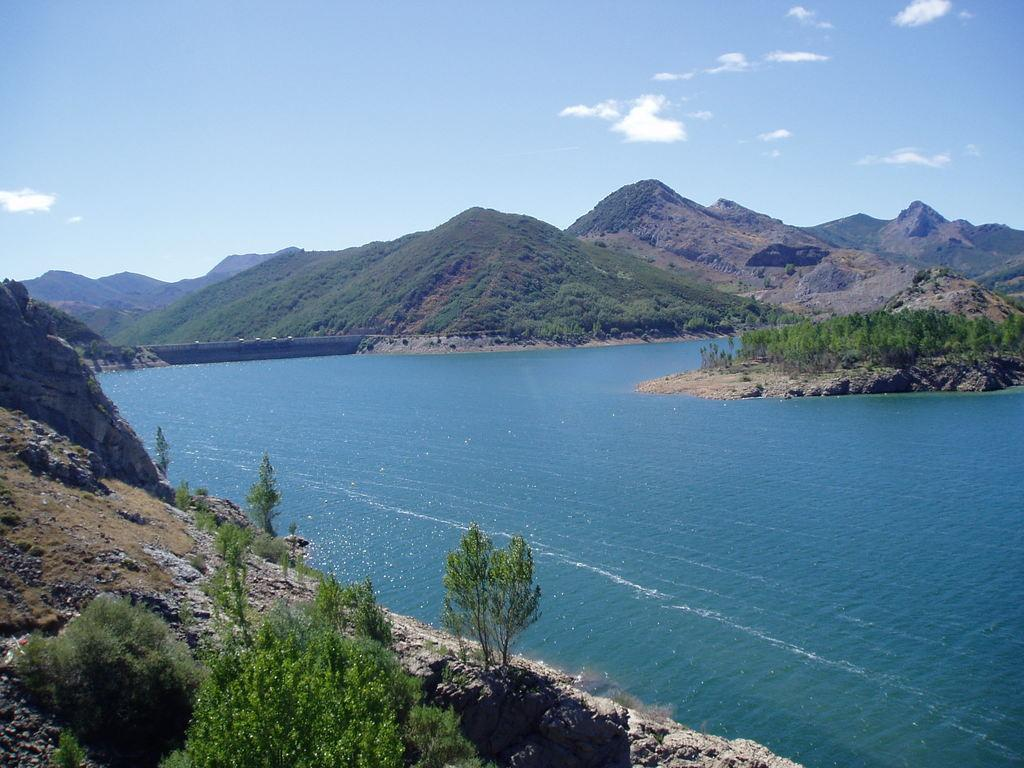What type of natural landform can be seen in the image? There are mountains in the image. What type of vegetation is present in the image? There are trees and grass in the image. What body of water is visible in the image? There is water visible in the image. How would you describe the sky in the image? The sky is cloudy and pale blue. Where is the cheese market located in the image? There is no cheese market present in the image. What type of rule governs the behavior of the mountains in the image? There are no rules governing the behavior of the mountains in the image, as they are a natural landform. 